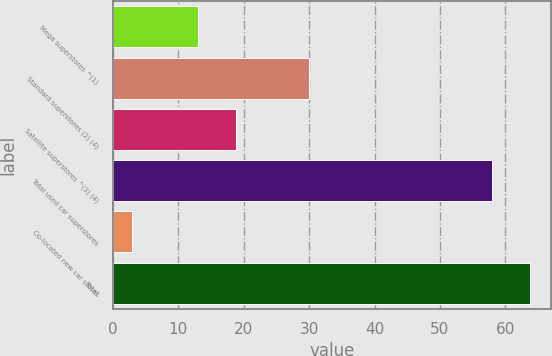<chart> <loc_0><loc_0><loc_500><loc_500><bar_chart><fcel>Mega superstores ^(1)<fcel>Standard superstores (2) (4)<fcel>Satellite superstores ^(3) (4)<fcel>Total used car superstores<fcel>Co-located new car stores<fcel>Total<nl><fcel>13<fcel>30<fcel>18.8<fcel>58<fcel>3<fcel>63.8<nl></chart> 